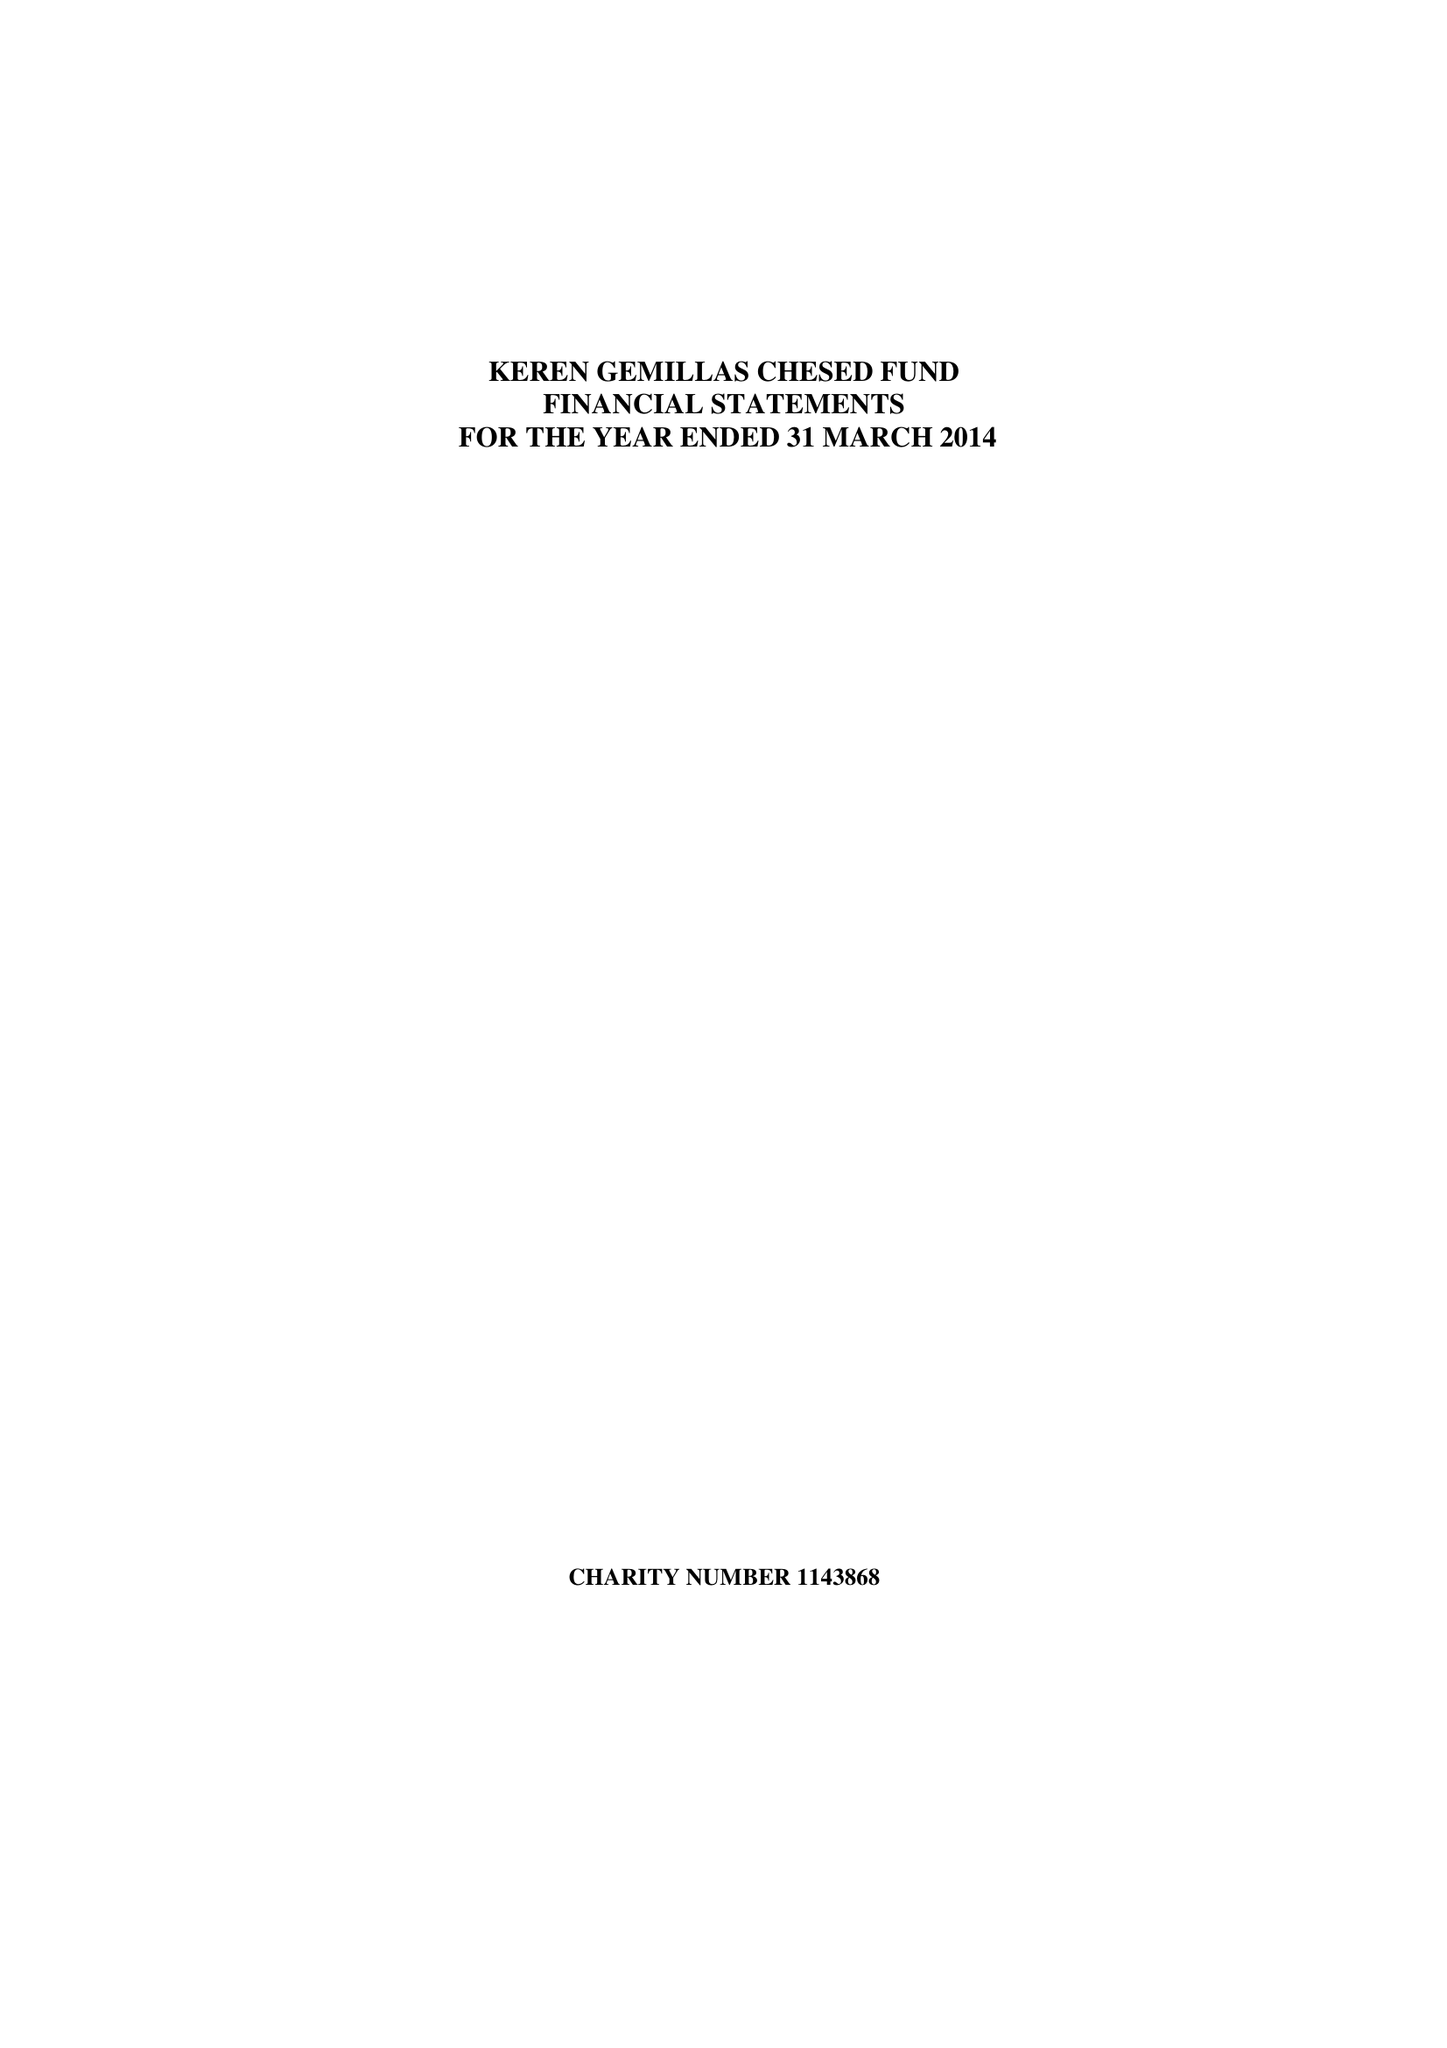What is the value for the income_annually_in_british_pounds?
Answer the question using a single word or phrase. 54043.00 